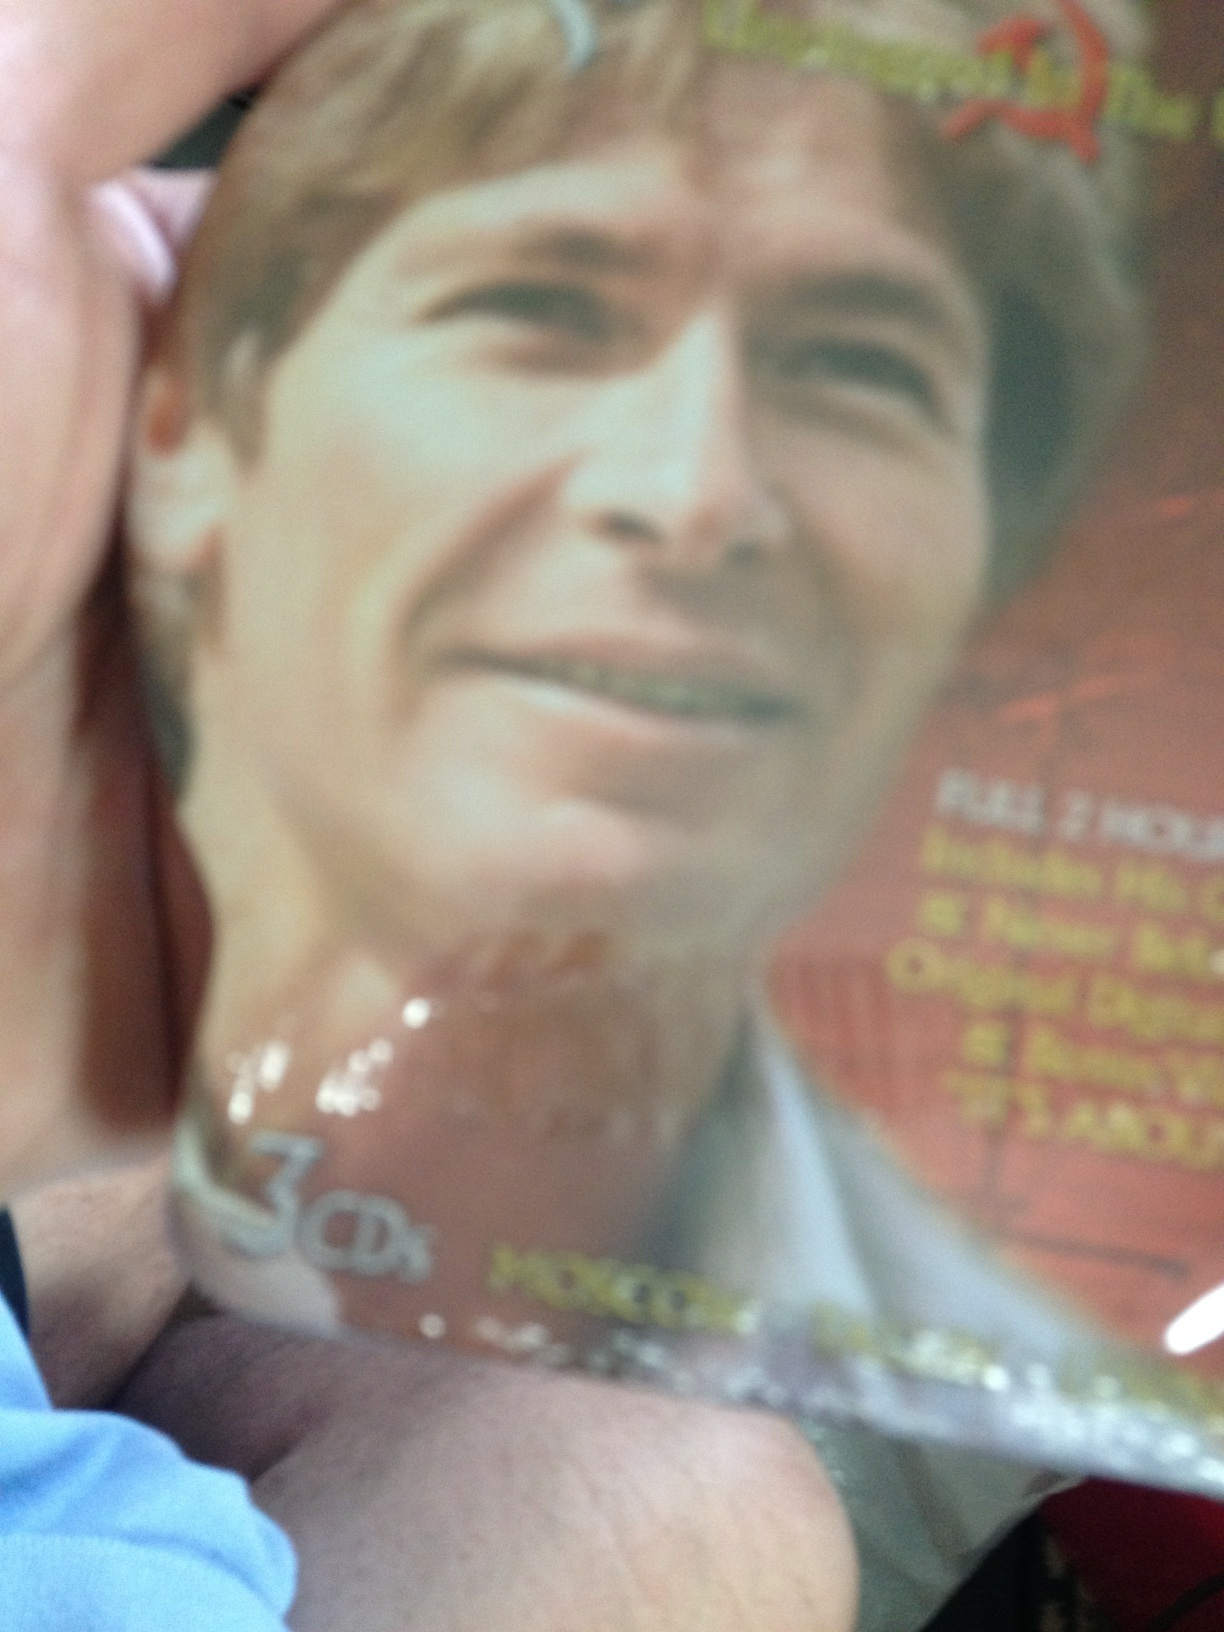What genre of music does this CD belong to? The image suggests that the CD might belong to a genre such as pop, rock, or folk, considering the appearance of the artist on the cover. However, without clear textual information, it's difficult to definitively identify the genre. Does the CD case indicate that there are multiple CDs included? Yes, the CD case indicates that there are 3 CDs included in this package. This often suggests it might be a special edition, a box set, or an extensive compilation of the artist's work. 